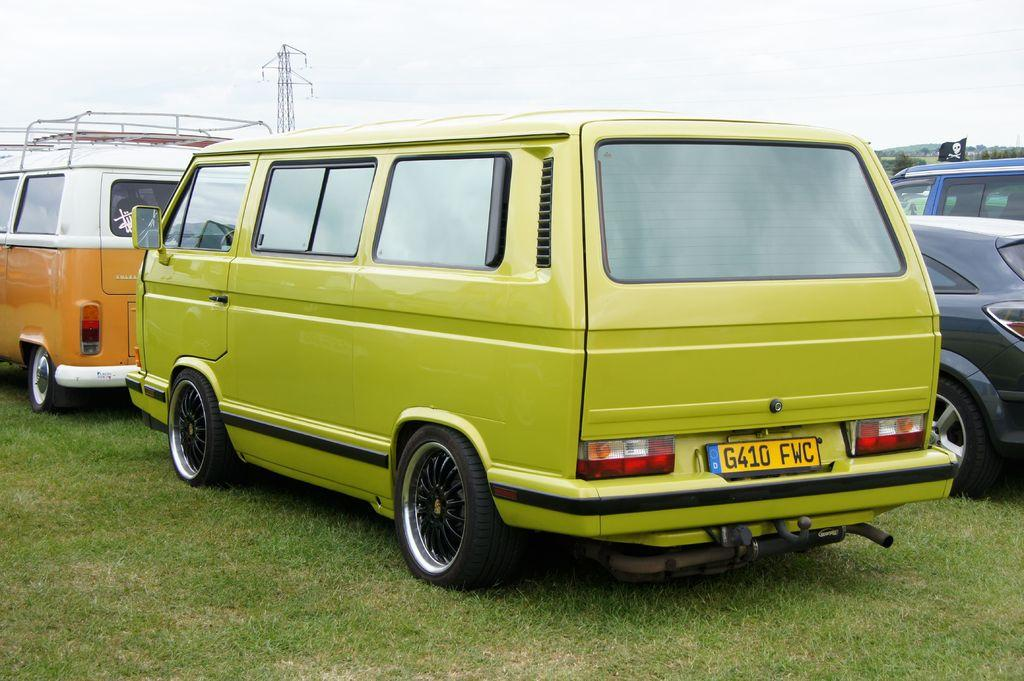<image>
Present a compact description of the photo's key features. A green van parked on the grass from Denmark. 